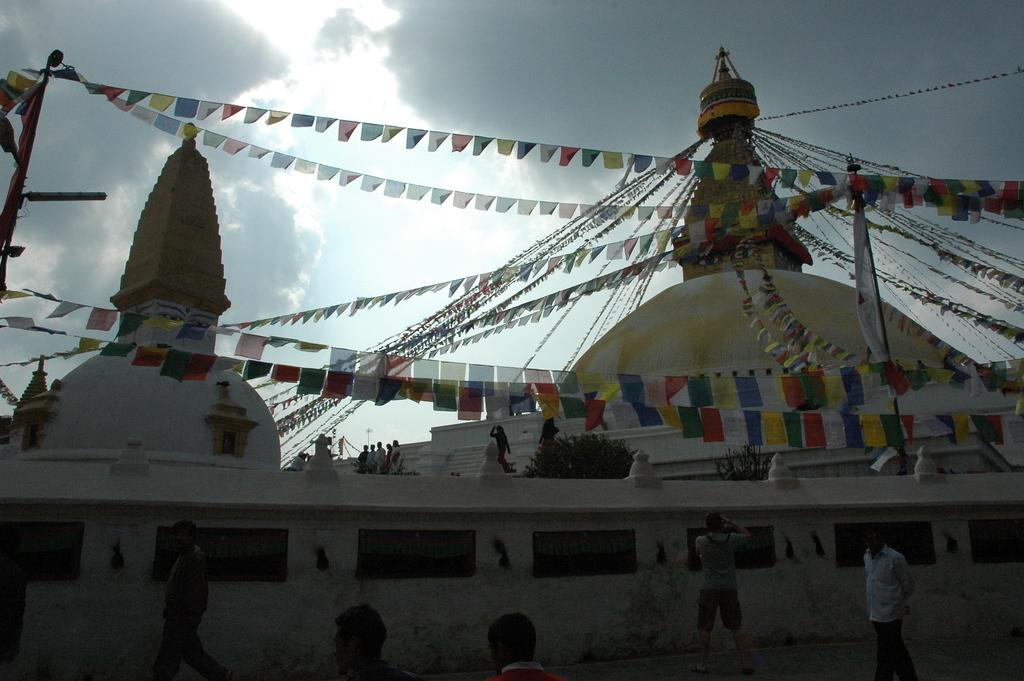What is the main feature of the buildings in the image? The buildings in the image are decorated with colorful flags. Can you describe the people in the image? There are people in the image, but their specific actions or appearances are not mentioned in the facts. What can be seen in the background of the image? There are clouds and the sky visible in the background of the image. What type of copy is being made by the people in the image? There is no mention of copying or any related activity in the image. What meal are the people in the image eating? There is no indication of a meal or any food in the image. 